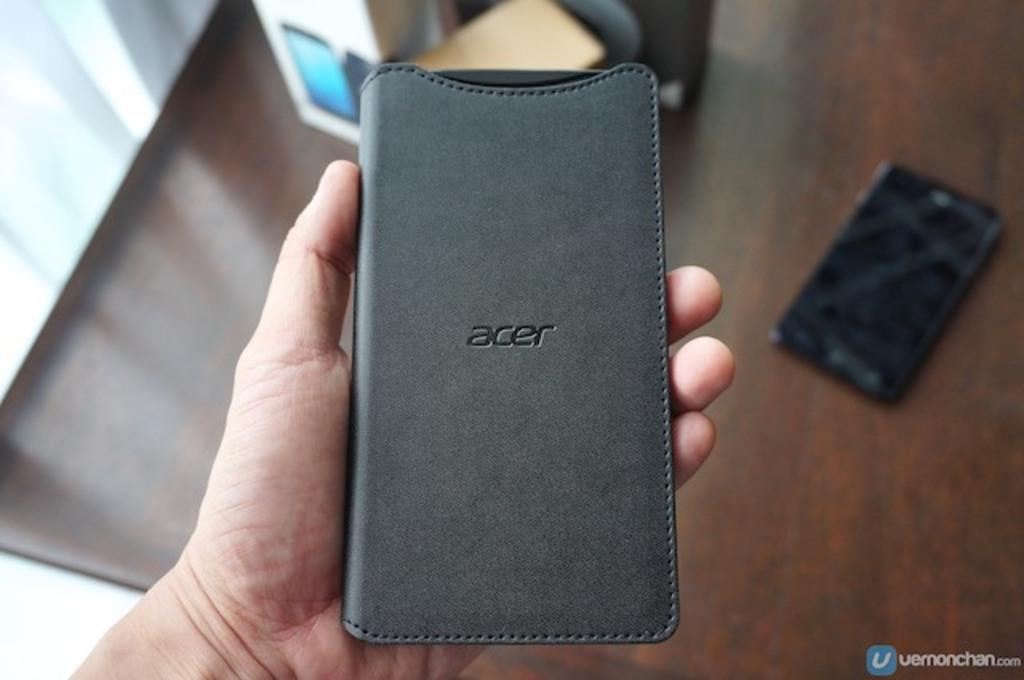Is this case made by acer?
Provide a succinct answer. Yes. What's in this case?
Ensure brevity in your answer.  Phone. 